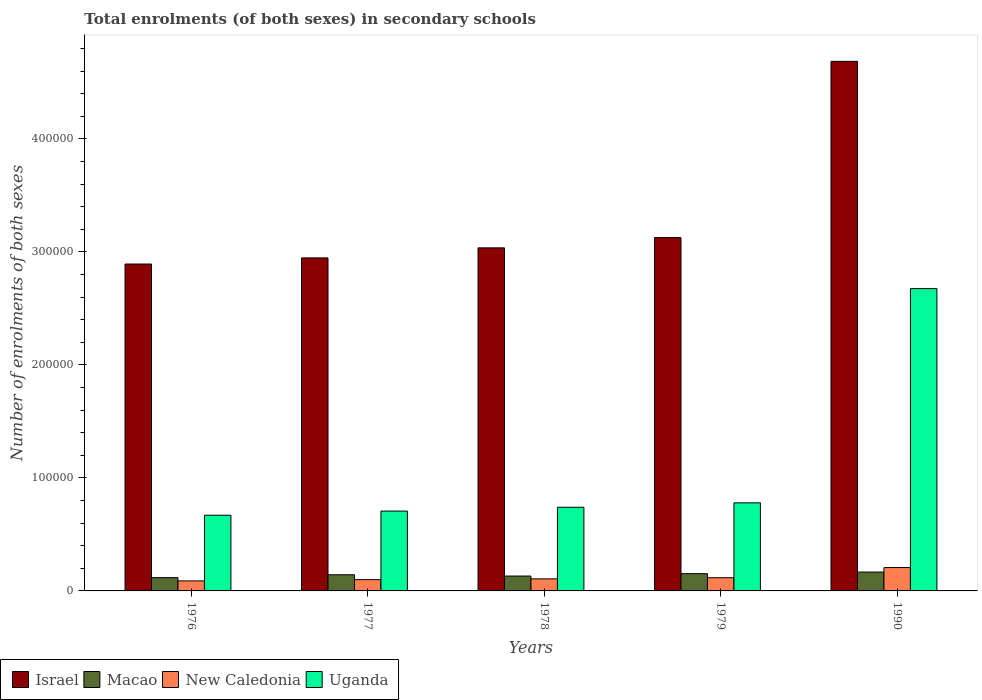Are the number of bars per tick equal to the number of legend labels?
Ensure brevity in your answer.  Yes. Are the number of bars on each tick of the X-axis equal?
Keep it short and to the point. Yes. How many bars are there on the 2nd tick from the right?
Give a very brief answer. 4. In how many cases, is the number of bars for a given year not equal to the number of legend labels?
Provide a succinct answer. 0. What is the number of enrolments in secondary schools in Macao in 1978?
Provide a succinct answer. 1.32e+04. Across all years, what is the maximum number of enrolments in secondary schools in Uganda?
Provide a short and direct response. 2.68e+05. Across all years, what is the minimum number of enrolments in secondary schools in New Caledonia?
Your answer should be very brief. 8862. In which year was the number of enrolments in secondary schools in Uganda maximum?
Give a very brief answer. 1990. In which year was the number of enrolments in secondary schools in Uganda minimum?
Your answer should be very brief. 1976. What is the total number of enrolments in secondary schools in Macao in the graph?
Provide a succinct answer. 7.12e+04. What is the difference between the number of enrolments in secondary schools in Israel in 1976 and that in 1977?
Make the answer very short. -5396. What is the difference between the number of enrolments in secondary schools in New Caledonia in 1977 and the number of enrolments in secondary schools in Macao in 1979?
Provide a short and direct response. -5275. What is the average number of enrolments in secondary schools in Israel per year?
Give a very brief answer. 3.34e+05. In the year 1990, what is the difference between the number of enrolments in secondary schools in New Caledonia and number of enrolments in secondary schools in Macao?
Your answer should be compact. 3986. In how many years, is the number of enrolments in secondary schools in New Caledonia greater than 60000?
Keep it short and to the point. 0. What is the ratio of the number of enrolments in secondary schools in Uganda in 1977 to that in 1990?
Your response must be concise. 0.26. Is the number of enrolments in secondary schools in New Caledonia in 1976 less than that in 1979?
Provide a short and direct response. Yes. What is the difference between the highest and the second highest number of enrolments in secondary schools in Macao?
Your answer should be very brief. 1419. What is the difference between the highest and the lowest number of enrolments in secondary schools in New Caledonia?
Give a very brief answer. 1.18e+04. Is it the case that in every year, the sum of the number of enrolments in secondary schools in Uganda and number of enrolments in secondary schools in Macao is greater than the sum of number of enrolments in secondary schools in New Caledonia and number of enrolments in secondary schools in Israel?
Give a very brief answer. Yes. What does the 3rd bar from the left in 1979 represents?
Provide a succinct answer. New Caledonia. What does the 1st bar from the right in 1977 represents?
Offer a very short reply. Uganda. Are all the bars in the graph horizontal?
Provide a short and direct response. No. Are the values on the major ticks of Y-axis written in scientific E-notation?
Make the answer very short. No. How many legend labels are there?
Keep it short and to the point. 4. What is the title of the graph?
Your answer should be very brief. Total enrolments (of both sexes) in secondary schools. What is the label or title of the X-axis?
Offer a very short reply. Years. What is the label or title of the Y-axis?
Give a very brief answer. Number of enrolments of both sexes. What is the Number of enrolments of both sexes in Israel in 1976?
Ensure brevity in your answer.  2.89e+05. What is the Number of enrolments of both sexes in Macao in 1976?
Your answer should be very brief. 1.18e+04. What is the Number of enrolments of both sexes of New Caledonia in 1976?
Your response must be concise. 8862. What is the Number of enrolments of both sexes of Uganda in 1976?
Make the answer very short. 6.70e+04. What is the Number of enrolments of both sexes of Israel in 1977?
Keep it short and to the point. 2.95e+05. What is the Number of enrolments of both sexes of Macao in 1977?
Ensure brevity in your answer.  1.43e+04. What is the Number of enrolments of both sexes in New Caledonia in 1977?
Offer a very short reply. 9993. What is the Number of enrolments of both sexes of Uganda in 1977?
Offer a very short reply. 7.06e+04. What is the Number of enrolments of both sexes of Israel in 1978?
Your answer should be very brief. 3.04e+05. What is the Number of enrolments of both sexes of Macao in 1978?
Your answer should be compact. 1.32e+04. What is the Number of enrolments of both sexes in New Caledonia in 1978?
Your answer should be very brief. 1.07e+04. What is the Number of enrolments of both sexes in Uganda in 1978?
Give a very brief answer. 7.40e+04. What is the Number of enrolments of both sexes in Israel in 1979?
Ensure brevity in your answer.  3.13e+05. What is the Number of enrolments of both sexes in Macao in 1979?
Your response must be concise. 1.53e+04. What is the Number of enrolments of both sexes in New Caledonia in 1979?
Your answer should be very brief. 1.17e+04. What is the Number of enrolments of both sexes in Uganda in 1979?
Your response must be concise. 7.79e+04. What is the Number of enrolments of both sexes of Israel in 1990?
Your response must be concise. 4.69e+05. What is the Number of enrolments of both sexes in Macao in 1990?
Your answer should be compact. 1.67e+04. What is the Number of enrolments of both sexes of New Caledonia in 1990?
Provide a succinct answer. 2.07e+04. What is the Number of enrolments of both sexes in Uganda in 1990?
Provide a short and direct response. 2.68e+05. Across all years, what is the maximum Number of enrolments of both sexes of Israel?
Keep it short and to the point. 4.69e+05. Across all years, what is the maximum Number of enrolments of both sexes of Macao?
Provide a succinct answer. 1.67e+04. Across all years, what is the maximum Number of enrolments of both sexes of New Caledonia?
Provide a succinct answer. 2.07e+04. Across all years, what is the maximum Number of enrolments of both sexes of Uganda?
Offer a terse response. 2.68e+05. Across all years, what is the minimum Number of enrolments of both sexes of Israel?
Your answer should be very brief. 2.89e+05. Across all years, what is the minimum Number of enrolments of both sexes of Macao?
Provide a succinct answer. 1.18e+04. Across all years, what is the minimum Number of enrolments of both sexes of New Caledonia?
Your answer should be compact. 8862. Across all years, what is the minimum Number of enrolments of both sexes in Uganda?
Offer a very short reply. 6.70e+04. What is the total Number of enrolments of both sexes in Israel in the graph?
Provide a succinct answer. 1.67e+06. What is the total Number of enrolments of both sexes in Macao in the graph?
Provide a short and direct response. 7.12e+04. What is the total Number of enrolments of both sexes of New Caledonia in the graph?
Keep it short and to the point. 6.19e+04. What is the total Number of enrolments of both sexes of Uganda in the graph?
Make the answer very short. 5.57e+05. What is the difference between the Number of enrolments of both sexes in Israel in 1976 and that in 1977?
Offer a very short reply. -5396. What is the difference between the Number of enrolments of both sexes of Macao in 1976 and that in 1977?
Your answer should be very brief. -2547. What is the difference between the Number of enrolments of both sexes in New Caledonia in 1976 and that in 1977?
Offer a terse response. -1131. What is the difference between the Number of enrolments of both sexes of Uganda in 1976 and that in 1977?
Provide a short and direct response. -3661. What is the difference between the Number of enrolments of both sexes of Israel in 1976 and that in 1978?
Give a very brief answer. -1.43e+04. What is the difference between the Number of enrolments of both sexes of Macao in 1976 and that in 1978?
Offer a terse response. -1392. What is the difference between the Number of enrolments of both sexes in New Caledonia in 1976 and that in 1978?
Provide a succinct answer. -1809. What is the difference between the Number of enrolments of both sexes of Uganda in 1976 and that in 1978?
Ensure brevity in your answer.  -7046. What is the difference between the Number of enrolments of both sexes in Israel in 1976 and that in 1979?
Your answer should be compact. -2.34e+04. What is the difference between the Number of enrolments of both sexes in Macao in 1976 and that in 1979?
Make the answer very short. -3510. What is the difference between the Number of enrolments of both sexes of New Caledonia in 1976 and that in 1979?
Provide a short and direct response. -2813. What is the difference between the Number of enrolments of both sexes in Uganda in 1976 and that in 1979?
Ensure brevity in your answer.  -1.09e+04. What is the difference between the Number of enrolments of both sexes in Israel in 1976 and that in 1990?
Keep it short and to the point. -1.79e+05. What is the difference between the Number of enrolments of both sexes of Macao in 1976 and that in 1990?
Provide a short and direct response. -4929. What is the difference between the Number of enrolments of both sexes of New Caledonia in 1976 and that in 1990?
Your answer should be compact. -1.18e+04. What is the difference between the Number of enrolments of both sexes of Uganda in 1976 and that in 1990?
Your answer should be very brief. -2.01e+05. What is the difference between the Number of enrolments of both sexes in Israel in 1977 and that in 1978?
Give a very brief answer. -8897. What is the difference between the Number of enrolments of both sexes in Macao in 1977 and that in 1978?
Your response must be concise. 1155. What is the difference between the Number of enrolments of both sexes in New Caledonia in 1977 and that in 1978?
Your answer should be compact. -678. What is the difference between the Number of enrolments of both sexes of Uganda in 1977 and that in 1978?
Offer a very short reply. -3385. What is the difference between the Number of enrolments of both sexes in Israel in 1977 and that in 1979?
Offer a very short reply. -1.80e+04. What is the difference between the Number of enrolments of both sexes of Macao in 1977 and that in 1979?
Provide a succinct answer. -963. What is the difference between the Number of enrolments of both sexes of New Caledonia in 1977 and that in 1979?
Ensure brevity in your answer.  -1682. What is the difference between the Number of enrolments of both sexes of Uganda in 1977 and that in 1979?
Your answer should be compact. -7282. What is the difference between the Number of enrolments of both sexes of Israel in 1977 and that in 1990?
Give a very brief answer. -1.74e+05. What is the difference between the Number of enrolments of both sexes in Macao in 1977 and that in 1990?
Provide a succinct answer. -2382. What is the difference between the Number of enrolments of both sexes of New Caledonia in 1977 and that in 1990?
Your answer should be very brief. -1.07e+04. What is the difference between the Number of enrolments of both sexes of Uganda in 1977 and that in 1990?
Make the answer very short. -1.97e+05. What is the difference between the Number of enrolments of both sexes in Israel in 1978 and that in 1979?
Provide a short and direct response. -9083. What is the difference between the Number of enrolments of both sexes in Macao in 1978 and that in 1979?
Provide a succinct answer. -2118. What is the difference between the Number of enrolments of both sexes of New Caledonia in 1978 and that in 1979?
Offer a very short reply. -1004. What is the difference between the Number of enrolments of both sexes of Uganda in 1978 and that in 1979?
Make the answer very short. -3897. What is the difference between the Number of enrolments of both sexes of Israel in 1978 and that in 1990?
Make the answer very short. -1.65e+05. What is the difference between the Number of enrolments of both sexes of Macao in 1978 and that in 1990?
Offer a terse response. -3537. What is the difference between the Number of enrolments of both sexes of New Caledonia in 1978 and that in 1990?
Give a very brief answer. -1.00e+04. What is the difference between the Number of enrolments of both sexes of Uganda in 1978 and that in 1990?
Make the answer very short. -1.93e+05. What is the difference between the Number of enrolments of both sexes of Israel in 1979 and that in 1990?
Offer a very short reply. -1.56e+05. What is the difference between the Number of enrolments of both sexes in Macao in 1979 and that in 1990?
Your response must be concise. -1419. What is the difference between the Number of enrolments of both sexes of New Caledonia in 1979 and that in 1990?
Provide a succinct answer. -8998. What is the difference between the Number of enrolments of both sexes in Uganda in 1979 and that in 1990?
Make the answer very short. -1.90e+05. What is the difference between the Number of enrolments of both sexes in Israel in 1976 and the Number of enrolments of both sexes in Macao in 1977?
Give a very brief answer. 2.75e+05. What is the difference between the Number of enrolments of both sexes in Israel in 1976 and the Number of enrolments of both sexes in New Caledonia in 1977?
Provide a short and direct response. 2.79e+05. What is the difference between the Number of enrolments of both sexes of Israel in 1976 and the Number of enrolments of both sexes of Uganda in 1977?
Provide a short and direct response. 2.19e+05. What is the difference between the Number of enrolments of both sexes in Macao in 1976 and the Number of enrolments of both sexes in New Caledonia in 1977?
Ensure brevity in your answer.  1765. What is the difference between the Number of enrolments of both sexes in Macao in 1976 and the Number of enrolments of both sexes in Uganda in 1977?
Provide a succinct answer. -5.89e+04. What is the difference between the Number of enrolments of both sexes of New Caledonia in 1976 and the Number of enrolments of both sexes of Uganda in 1977?
Your answer should be very brief. -6.18e+04. What is the difference between the Number of enrolments of both sexes in Israel in 1976 and the Number of enrolments of both sexes in Macao in 1978?
Your response must be concise. 2.76e+05. What is the difference between the Number of enrolments of both sexes of Israel in 1976 and the Number of enrolments of both sexes of New Caledonia in 1978?
Offer a very short reply. 2.79e+05. What is the difference between the Number of enrolments of both sexes in Israel in 1976 and the Number of enrolments of both sexes in Uganda in 1978?
Offer a very short reply. 2.15e+05. What is the difference between the Number of enrolments of both sexes in Macao in 1976 and the Number of enrolments of both sexes in New Caledonia in 1978?
Make the answer very short. 1087. What is the difference between the Number of enrolments of both sexes of Macao in 1976 and the Number of enrolments of both sexes of Uganda in 1978?
Ensure brevity in your answer.  -6.23e+04. What is the difference between the Number of enrolments of both sexes of New Caledonia in 1976 and the Number of enrolments of both sexes of Uganda in 1978?
Your response must be concise. -6.52e+04. What is the difference between the Number of enrolments of both sexes in Israel in 1976 and the Number of enrolments of both sexes in Macao in 1979?
Provide a succinct answer. 2.74e+05. What is the difference between the Number of enrolments of both sexes in Israel in 1976 and the Number of enrolments of both sexes in New Caledonia in 1979?
Offer a very short reply. 2.78e+05. What is the difference between the Number of enrolments of both sexes of Israel in 1976 and the Number of enrolments of both sexes of Uganda in 1979?
Your answer should be compact. 2.11e+05. What is the difference between the Number of enrolments of both sexes in Macao in 1976 and the Number of enrolments of both sexes in Uganda in 1979?
Your answer should be compact. -6.62e+04. What is the difference between the Number of enrolments of both sexes of New Caledonia in 1976 and the Number of enrolments of both sexes of Uganda in 1979?
Your answer should be compact. -6.91e+04. What is the difference between the Number of enrolments of both sexes in Israel in 1976 and the Number of enrolments of both sexes in Macao in 1990?
Offer a terse response. 2.73e+05. What is the difference between the Number of enrolments of both sexes of Israel in 1976 and the Number of enrolments of both sexes of New Caledonia in 1990?
Offer a terse response. 2.69e+05. What is the difference between the Number of enrolments of both sexes of Israel in 1976 and the Number of enrolments of both sexes of Uganda in 1990?
Make the answer very short. 2.18e+04. What is the difference between the Number of enrolments of both sexes in Macao in 1976 and the Number of enrolments of both sexes in New Caledonia in 1990?
Keep it short and to the point. -8915. What is the difference between the Number of enrolments of both sexes in Macao in 1976 and the Number of enrolments of both sexes in Uganda in 1990?
Your answer should be very brief. -2.56e+05. What is the difference between the Number of enrolments of both sexes in New Caledonia in 1976 and the Number of enrolments of both sexes in Uganda in 1990?
Your answer should be compact. -2.59e+05. What is the difference between the Number of enrolments of both sexes of Israel in 1977 and the Number of enrolments of both sexes of Macao in 1978?
Ensure brevity in your answer.  2.82e+05. What is the difference between the Number of enrolments of both sexes of Israel in 1977 and the Number of enrolments of both sexes of New Caledonia in 1978?
Your response must be concise. 2.84e+05. What is the difference between the Number of enrolments of both sexes of Israel in 1977 and the Number of enrolments of both sexes of Uganda in 1978?
Offer a very short reply. 2.21e+05. What is the difference between the Number of enrolments of both sexes of Macao in 1977 and the Number of enrolments of both sexes of New Caledonia in 1978?
Ensure brevity in your answer.  3634. What is the difference between the Number of enrolments of both sexes in Macao in 1977 and the Number of enrolments of both sexes in Uganda in 1978?
Ensure brevity in your answer.  -5.97e+04. What is the difference between the Number of enrolments of both sexes in New Caledonia in 1977 and the Number of enrolments of both sexes in Uganda in 1978?
Offer a terse response. -6.40e+04. What is the difference between the Number of enrolments of both sexes in Israel in 1977 and the Number of enrolments of both sexes in Macao in 1979?
Make the answer very short. 2.79e+05. What is the difference between the Number of enrolments of both sexes in Israel in 1977 and the Number of enrolments of both sexes in New Caledonia in 1979?
Give a very brief answer. 2.83e+05. What is the difference between the Number of enrolments of both sexes of Israel in 1977 and the Number of enrolments of both sexes of Uganda in 1979?
Offer a terse response. 2.17e+05. What is the difference between the Number of enrolments of both sexes of Macao in 1977 and the Number of enrolments of both sexes of New Caledonia in 1979?
Give a very brief answer. 2630. What is the difference between the Number of enrolments of both sexes in Macao in 1977 and the Number of enrolments of both sexes in Uganda in 1979?
Give a very brief answer. -6.36e+04. What is the difference between the Number of enrolments of both sexes in New Caledonia in 1977 and the Number of enrolments of both sexes in Uganda in 1979?
Your answer should be very brief. -6.79e+04. What is the difference between the Number of enrolments of both sexes of Israel in 1977 and the Number of enrolments of both sexes of Macao in 1990?
Offer a very short reply. 2.78e+05. What is the difference between the Number of enrolments of both sexes of Israel in 1977 and the Number of enrolments of both sexes of New Caledonia in 1990?
Offer a very short reply. 2.74e+05. What is the difference between the Number of enrolments of both sexes in Israel in 1977 and the Number of enrolments of both sexes in Uganda in 1990?
Give a very brief answer. 2.72e+04. What is the difference between the Number of enrolments of both sexes of Macao in 1977 and the Number of enrolments of both sexes of New Caledonia in 1990?
Give a very brief answer. -6368. What is the difference between the Number of enrolments of both sexes of Macao in 1977 and the Number of enrolments of both sexes of Uganda in 1990?
Make the answer very short. -2.53e+05. What is the difference between the Number of enrolments of both sexes in New Caledonia in 1977 and the Number of enrolments of both sexes in Uganda in 1990?
Keep it short and to the point. -2.58e+05. What is the difference between the Number of enrolments of both sexes in Israel in 1978 and the Number of enrolments of both sexes in Macao in 1979?
Your response must be concise. 2.88e+05. What is the difference between the Number of enrolments of both sexes in Israel in 1978 and the Number of enrolments of both sexes in New Caledonia in 1979?
Keep it short and to the point. 2.92e+05. What is the difference between the Number of enrolments of both sexes in Israel in 1978 and the Number of enrolments of both sexes in Uganda in 1979?
Make the answer very short. 2.26e+05. What is the difference between the Number of enrolments of both sexes in Macao in 1978 and the Number of enrolments of both sexes in New Caledonia in 1979?
Give a very brief answer. 1475. What is the difference between the Number of enrolments of both sexes in Macao in 1978 and the Number of enrolments of both sexes in Uganda in 1979?
Give a very brief answer. -6.48e+04. What is the difference between the Number of enrolments of both sexes of New Caledonia in 1978 and the Number of enrolments of both sexes of Uganda in 1979?
Your response must be concise. -6.73e+04. What is the difference between the Number of enrolments of both sexes in Israel in 1978 and the Number of enrolments of both sexes in Macao in 1990?
Ensure brevity in your answer.  2.87e+05. What is the difference between the Number of enrolments of both sexes of Israel in 1978 and the Number of enrolments of both sexes of New Caledonia in 1990?
Provide a short and direct response. 2.83e+05. What is the difference between the Number of enrolments of both sexes in Israel in 1978 and the Number of enrolments of both sexes in Uganda in 1990?
Your response must be concise. 3.61e+04. What is the difference between the Number of enrolments of both sexes of Macao in 1978 and the Number of enrolments of both sexes of New Caledonia in 1990?
Your response must be concise. -7523. What is the difference between the Number of enrolments of both sexes in Macao in 1978 and the Number of enrolments of both sexes in Uganda in 1990?
Your answer should be very brief. -2.54e+05. What is the difference between the Number of enrolments of both sexes in New Caledonia in 1978 and the Number of enrolments of both sexes in Uganda in 1990?
Make the answer very short. -2.57e+05. What is the difference between the Number of enrolments of both sexes in Israel in 1979 and the Number of enrolments of both sexes in Macao in 1990?
Provide a short and direct response. 2.96e+05. What is the difference between the Number of enrolments of both sexes in Israel in 1979 and the Number of enrolments of both sexes in New Caledonia in 1990?
Make the answer very short. 2.92e+05. What is the difference between the Number of enrolments of both sexes of Israel in 1979 and the Number of enrolments of both sexes of Uganda in 1990?
Keep it short and to the point. 4.51e+04. What is the difference between the Number of enrolments of both sexes in Macao in 1979 and the Number of enrolments of both sexes in New Caledonia in 1990?
Your response must be concise. -5405. What is the difference between the Number of enrolments of both sexes in Macao in 1979 and the Number of enrolments of both sexes in Uganda in 1990?
Offer a very short reply. -2.52e+05. What is the difference between the Number of enrolments of both sexes in New Caledonia in 1979 and the Number of enrolments of both sexes in Uganda in 1990?
Your answer should be compact. -2.56e+05. What is the average Number of enrolments of both sexes of Israel per year?
Offer a very short reply. 3.34e+05. What is the average Number of enrolments of both sexes of Macao per year?
Give a very brief answer. 1.42e+04. What is the average Number of enrolments of both sexes in New Caledonia per year?
Give a very brief answer. 1.24e+04. What is the average Number of enrolments of both sexes of Uganda per year?
Provide a succinct answer. 1.11e+05. In the year 1976, what is the difference between the Number of enrolments of both sexes of Israel and Number of enrolments of both sexes of Macao?
Offer a very short reply. 2.78e+05. In the year 1976, what is the difference between the Number of enrolments of both sexes of Israel and Number of enrolments of both sexes of New Caledonia?
Your answer should be compact. 2.80e+05. In the year 1976, what is the difference between the Number of enrolments of both sexes of Israel and Number of enrolments of both sexes of Uganda?
Your answer should be very brief. 2.22e+05. In the year 1976, what is the difference between the Number of enrolments of both sexes of Macao and Number of enrolments of both sexes of New Caledonia?
Offer a terse response. 2896. In the year 1976, what is the difference between the Number of enrolments of both sexes in Macao and Number of enrolments of both sexes in Uganda?
Give a very brief answer. -5.52e+04. In the year 1976, what is the difference between the Number of enrolments of both sexes of New Caledonia and Number of enrolments of both sexes of Uganda?
Offer a terse response. -5.81e+04. In the year 1977, what is the difference between the Number of enrolments of both sexes in Israel and Number of enrolments of both sexes in Macao?
Offer a very short reply. 2.80e+05. In the year 1977, what is the difference between the Number of enrolments of both sexes of Israel and Number of enrolments of both sexes of New Caledonia?
Offer a terse response. 2.85e+05. In the year 1977, what is the difference between the Number of enrolments of both sexes in Israel and Number of enrolments of both sexes in Uganda?
Provide a short and direct response. 2.24e+05. In the year 1977, what is the difference between the Number of enrolments of both sexes of Macao and Number of enrolments of both sexes of New Caledonia?
Provide a short and direct response. 4312. In the year 1977, what is the difference between the Number of enrolments of both sexes in Macao and Number of enrolments of both sexes in Uganda?
Provide a short and direct response. -5.63e+04. In the year 1977, what is the difference between the Number of enrolments of both sexes of New Caledonia and Number of enrolments of both sexes of Uganda?
Your response must be concise. -6.07e+04. In the year 1978, what is the difference between the Number of enrolments of both sexes in Israel and Number of enrolments of both sexes in Macao?
Keep it short and to the point. 2.90e+05. In the year 1978, what is the difference between the Number of enrolments of both sexes in Israel and Number of enrolments of both sexes in New Caledonia?
Provide a short and direct response. 2.93e+05. In the year 1978, what is the difference between the Number of enrolments of both sexes in Israel and Number of enrolments of both sexes in Uganda?
Give a very brief answer. 2.30e+05. In the year 1978, what is the difference between the Number of enrolments of both sexes in Macao and Number of enrolments of both sexes in New Caledonia?
Provide a short and direct response. 2479. In the year 1978, what is the difference between the Number of enrolments of both sexes of Macao and Number of enrolments of both sexes of Uganda?
Your answer should be compact. -6.09e+04. In the year 1978, what is the difference between the Number of enrolments of both sexes in New Caledonia and Number of enrolments of both sexes in Uganda?
Ensure brevity in your answer.  -6.34e+04. In the year 1979, what is the difference between the Number of enrolments of both sexes of Israel and Number of enrolments of both sexes of Macao?
Your response must be concise. 2.97e+05. In the year 1979, what is the difference between the Number of enrolments of both sexes in Israel and Number of enrolments of both sexes in New Caledonia?
Your response must be concise. 3.01e+05. In the year 1979, what is the difference between the Number of enrolments of both sexes of Israel and Number of enrolments of both sexes of Uganda?
Provide a succinct answer. 2.35e+05. In the year 1979, what is the difference between the Number of enrolments of both sexes in Macao and Number of enrolments of both sexes in New Caledonia?
Offer a very short reply. 3593. In the year 1979, what is the difference between the Number of enrolments of both sexes in Macao and Number of enrolments of both sexes in Uganda?
Offer a very short reply. -6.27e+04. In the year 1979, what is the difference between the Number of enrolments of both sexes of New Caledonia and Number of enrolments of both sexes of Uganda?
Make the answer very short. -6.63e+04. In the year 1990, what is the difference between the Number of enrolments of both sexes of Israel and Number of enrolments of both sexes of Macao?
Provide a short and direct response. 4.52e+05. In the year 1990, what is the difference between the Number of enrolments of both sexes of Israel and Number of enrolments of both sexes of New Caledonia?
Your answer should be very brief. 4.48e+05. In the year 1990, what is the difference between the Number of enrolments of both sexes in Israel and Number of enrolments of both sexes in Uganda?
Your response must be concise. 2.01e+05. In the year 1990, what is the difference between the Number of enrolments of both sexes of Macao and Number of enrolments of both sexes of New Caledonia?
Make the answer very short. -3986. In the year 1990, what is the difference between the Number of enrolments of both sexes of Macao and Number of enrolments of both sexes of Uganda?
Offer a very short reply. -2.51e+05. In the year 1990, what is the difference between the Number of enrolments of both sexes of New Caledonia and Number of enrolments of both sexes of Uganda?
Your response must be concise. -2.47e+05. What is the ratio of the Number of enrolments of both sexes in Israel in 1976 to that in 1977?
Your answer should be compact. 0.98. What is the ratio of the Number of enrolments of both sexes of Macao in 1976 to that in 1977?
Provide a succinct answer. 0.82. What is the ratio of the Number of enrolments of both sexes in New Caledonia in 1976 to that in 1977?
Your answer should be compact. 0.89. What is the ratio of the Number of enrolments of both sexes of Uganda in 1976 to that in 1977?
Offer a terse response. 0.95. What is the ratio of the Number of enrolments of both sexes of Israel in 1976 to that in 1978?
Keep it short and to the point. 0.95. What is the ratio of the Number of enrolments of both sexes in Macao in 1976 to that in 1978?
Your response must be concise. 0.89. What is the ratio of the Number of enrolments of both sexes in New Caledonia in 1976 to that in 1978?
Your answer should be compact. 0.83. What is the ratio of the Number of enrolments of both sexes in Uganda in 1976 to that in 1978?
Offer a very short reply. 0.9. What is the ratio of the Number of enrolments of both sexes in Israel in 1976 to that in 1979?
Offer a very short reply. 0.93. What is the ratio of the Number of enrolments of both sexes of Macao in 1976 to that in 1979?
Your answer should be very brief. 0.77. What is the ratio of the Number of enrolments of both sexes in New Caledonia in 1976 to that in 1979?
Keep it short and to the point. 0.76. What is the ratio of the Number of enrolments of both sexes in Uganda in 1976 to that in 1979?
Provide a short and direct response. 0.86. What is the ratio of the Number of enrolments of both sexes in Israel in 1976 to that in 1990?
Your answer should be very brief. 0.62. What is the ratio of the Number of enrolments of both sexes in Macao in 1976 to that in 1990?
Keep it short and to the point. 0.7. What is the ratio of the Number of enrolments of both sexes of New Caledonia in 1976 to that in 1990?
Make the answer very short. 0.43. What is the ratio of the Number of enrolments of both sexes of Uganda in 1976 to that in 1990?
Your response must be concise. 0.25. What is the ratio of the Number of enrolments of both sexes of Israel in 1977 to that in 1978?
Your response must be concise. 0.97. What is the ratio of the Number of enrolments of both sexes of Macao in 1977 to that in 1978?
Provide a short and direct response. 1.09. What is the ratio of the Number of enrolments of both sexes in New Caledonia in 1977 to that in 1978?
Give a very brief answer. 0.94. What is the ratio of the Number of enrolments of both sexes in Uganda in 1977 to that in 1978?
Offer a very short reply. 0.95. What is the ratio of the Number of enrolments of both sexes in Israel in 1977 to that in 1979?
Make the answer very short. 0.94. What is the ratio of the Number of enrolments of both sexes in Macao in 1977 to that in 1979?
Make the answer very short. 0.94. What is the ratio of the Number of enrolments of both sexes in New Caledonia in 1977 to that in 1979?
Ensure brevity in your answer.  0.86. What is the ratio of the Number of enrolments of both sexes of Uganda in 1977 to that in 1979?
Ensure brevity in your answer.  0.91. What is the ratio of the Number of enrolments of both sexes of Israel in 1977 to that in 1990?
Give a very brief answer. 0.63. What is the ratio of the Number of enrolments of both sexes in Macao in 1977 to that in 1990?
Ensure brevity in your answer.  0.86. What is the ratio of the Number of enrolments of both sexes of New Caledonia in 1977 to that in 1990?
Make the answer very short. 0.48. What is the ratio of the Number of enrolments of both sexes of Uganda in 1977 to that in 1990?
Keep it short and to the point. 0.26. What is the ratio of the Number of enrolments of both sexes of Israel in 1978 to that in 1979?
Offer a very short reply. 0.97. What is the ratio of the Number of enrolments of both sexes of Macao in 1978 to that in 1979?
Give a very brief answer. 0.86. What is the ratio of the Number of enrolments of both sexes in New Caledonia in 1978 to that in 1979?
Your answer should be very brief. 0.91. What is the ratio of the Number of enrolments of both sexes of Israel in 1978 to that in 1990?
Ensure brevity in your answer.  0.65. What is the ratio of the Number of enrolments of both sexes of Macao in 1978 to that in 1990?
Provide a succinct answer. 0.79. What is the ratio of the Number of enrolments of both sexes in New Caledonia in 1978 to that in 1990?
Your answer should be compact. 0.52. What is the ratio of the Number of enrolments of both sexes of Uganda in 1978 to that in 1990?
Ensure brevity in your answer.  0.28. What is the ratio of the Number of enrolments of both sexes in Israel in 1979 to that in 1990?
Your answer should be very brief. 0.67. What is the ratio of the Number of enrolments of both sexes in Macao in 1979 to that in 1990?
Provide a succinct answer. 0.92. What is the ratio of the Number of enrolments of both sexes in New Caledonia in 1979 to that in 1990?
Your response must be concise. 0.56. What is the ratio of the Number of enrolments of both sexes of Uganda in 1979 to that in 1990?
Make the answer very short. 0.29. What is the difference between the highest and the second highest Number of enrolments of both sexes in Israel?
Your answer should be compact. 1.56e+05. What is the difference between the highest and the second highest Number of enrolments of both sexes in Macao?
Provide a short and direct response. 1419. What is the difference between the highest and the second highest Number of enrolments of both sexes of New Caledonia?
Make the answer very short. 8998. What is the difference between the highest and the second highest Number of enrolments of both sexes in Uganda?
Offer a very short reply. 1.90e+05. What is the difference between the highest and the lowest Number of enrolments of both sexes of Israel?
Offer a very short reply. 1.79e+05. What is the difference between the highest and the lowest Number of enrolments of both sexes in Macao?
Make the answer very short. 4929. What is the difference between the highest and the lowest Number of enrolments of both sexes of New Caledonia?
Give a very brief answer. 1.18e+04. What is the difference between the highest and the lowest Number of enrolments of both sexes in Uganda?
Provide a succinct answer. 2.01e+05. 